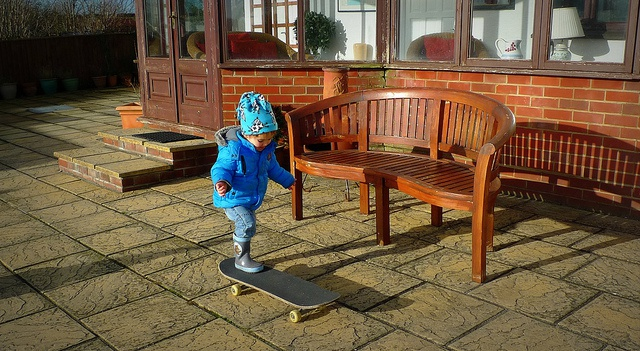Describe the objects in this image and their specific colors. I can see bench in black, maroon, brown, and gray tones, people in black, navy, darkblue, and lightblue tones, skateboard in black, gray, and darkgreen tones, potted plant in black and gray tones, and potted plant in black, gray, and darkgreen tones in this image. 